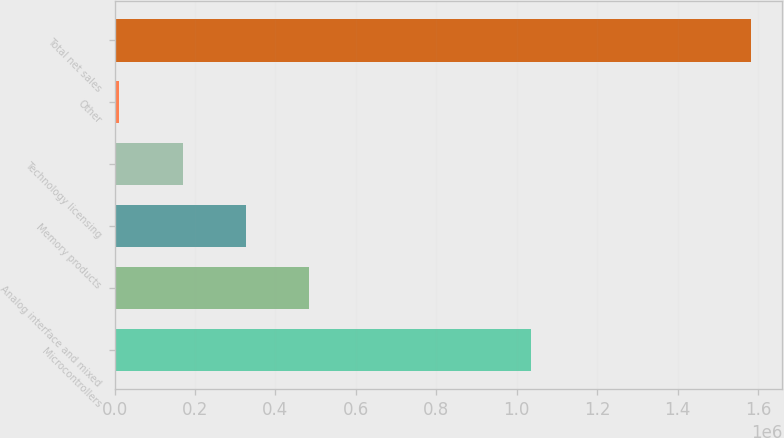Convert chart. <chart><loc_0><loc_0><loc_500><loc_500><bar_chart><fcel>Microcontrollers<fcel>Analog interface and mixed<fcel>Memory products<fcel>Technology licensing<fcel>Other<fcel>Total net sales<nl><fcel>1.03551e+06<fcel>482905<fcel>325945<fcel>168986<fcel>12026<fcel>1.58162e+06<nl></chart> 